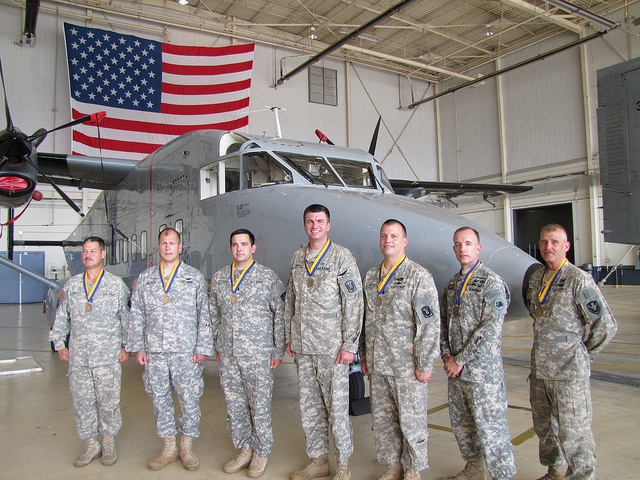Describe the objects in this image and their specific colors. I can see airplane in gray, darkgray, and black tones, people in gray, darkgray, and black tones, people in gray, darkgray, and lightgray tones, people in gray, darkgray, and lightgray tones, and people in gray, darkgray, lightgray, and black tones in this image. 